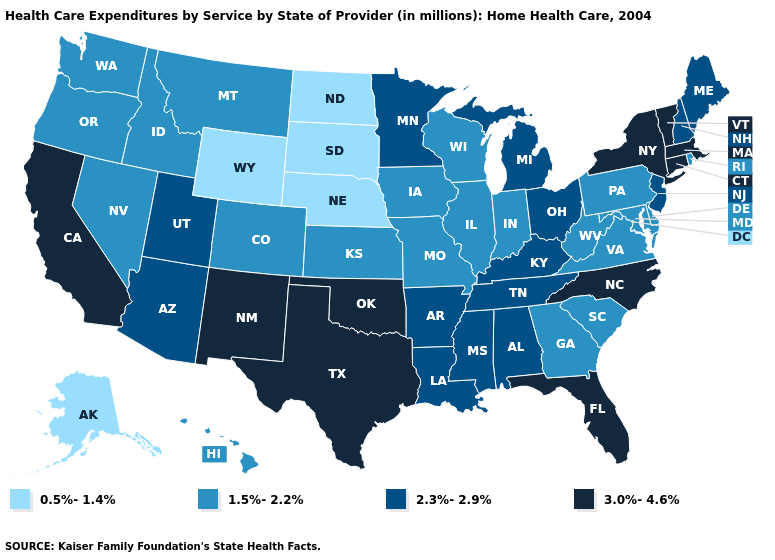Does Kentucky have the lowest value in the USA?
Concise answer only. No. Name the states that have a value in the range 3.0%-4.6%?
Give a very brief answer. California, Connecticut, Florida, Massachusetts, New Mexico, New York, North Carolina, Oklahoma, Texas, Vermont. Does California have the highest value in the USA?
Concise answer only. Yes. Name the states that have a value in the range 2.3%-2.9%?
Quick response, please. Alabama, Arizona, Arkansas, Kentucky, Louisiana, Maine, Michigan, Minnesota, Mississippi, New Hampshire, New Jersey, Ohio, Tennessee, Utah. Does North Dakota have the highest value in the MidWest?
Quick response, please. No. Does Wisconsin have the highest value in the USA?
Short answer required. No. Among the states that border Nevada , does Arizona have the highest value?
Short answer required. No. Name the states that have a value in the range 0.5%-1.4%?
Keep it brief. Alaska, Nebraska, North Dakota, South Dakota, Wyoming. What is the value of Vermont?
Concise answer only. 3.0%-4.6%. What is the value of Texas?
Short answer required. 3.0%-4.6%. Name the states that have a value in the range 0.5%-1.4%?
Answer briefly. Alaska, Nebraska, North Dakota, South Dakota, Wyoming. Does Washington have the highest value in the USA?
Give a very brief answer. No. What is the highest value in the USA?
Short answer required. 3.0%-4.6%. Among the states that border Idaho , does Nevada have the highest value?
Be succinct. No. Which states have the lowest value in the USA?
Short answer required. Alaska, Nebraska, North Dakota, South Dakota, Wyoming. 